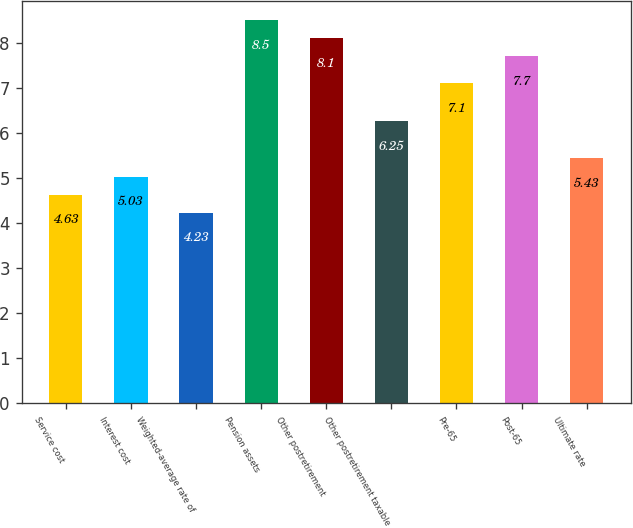Convert chart to OTSL. <chart><loc_0><loc_0><loc_500><loc_500><bar_chart><fcel>Service cost<fcel>Interest cost<fcel>Weighted-average rate of<fcel>Pension assets<fcel>Other postretirement<fcel>Other postretirement taxable<fcel>Pre-65<fcel>Post-65<fcel>Ultimate rate<nl><fcel>4.63<fcel>5.03<fcel>4.23<fcel>8.5<fcel>8.1<fcel>6.25<fcel>7.1<fcel>7.7<fcel>5.43<nl></chart> 